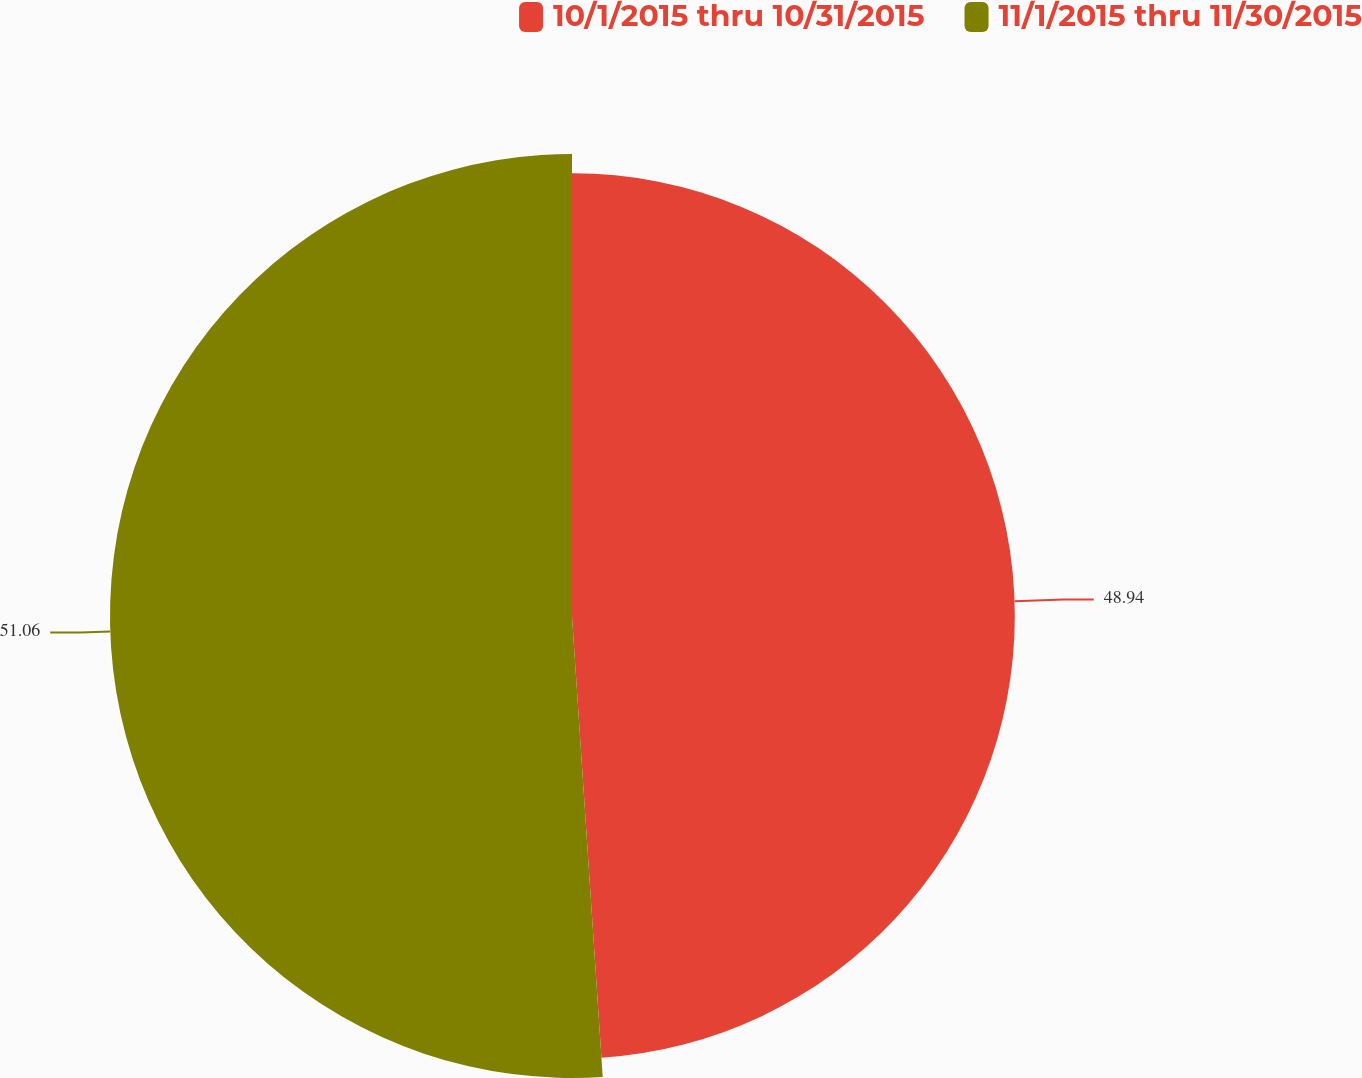Convert chart. <chart><loc_0><loc_0><loc_500><loc_500><pie_chart><fcel>10/1/2015 thru 10/31/2015<fcel>11/1/2015 thru 11/30/2015<nl><fcel>48.94%<fcel>51.06%<nl></chart> 